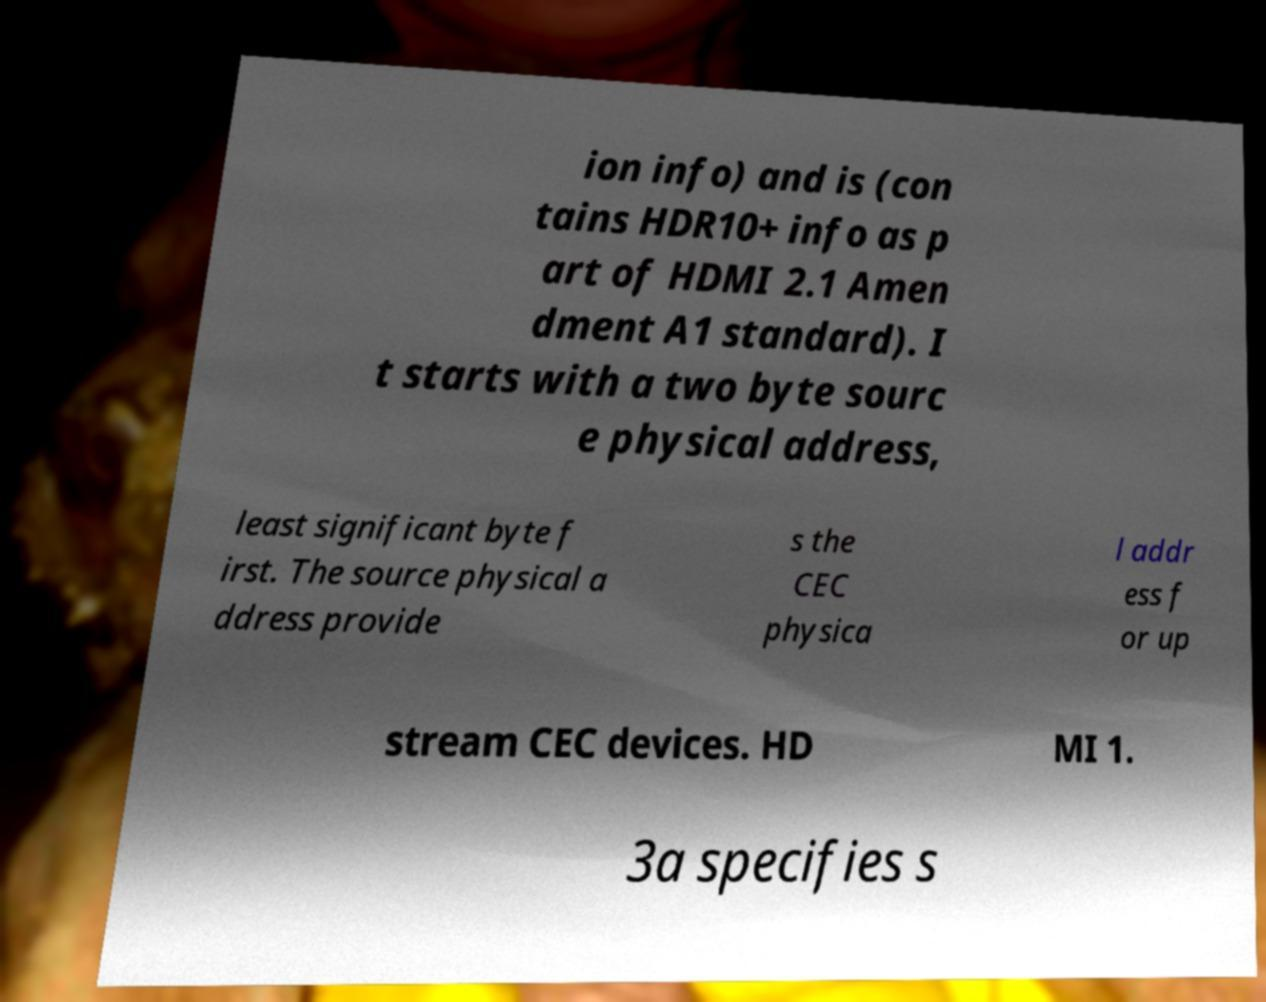Could you extract and type out the text from this image? ion info) and is (con tains HDR10+ info as p art of HDMI 2.1 Amen dment A1 standard). I t starts with a two byte sourc e physical address, least significant byte f irst. The source physical a ddress provide s the CEC physica l addr ess f or up stream CEC devices. HD MI 1. 3a specifies s 